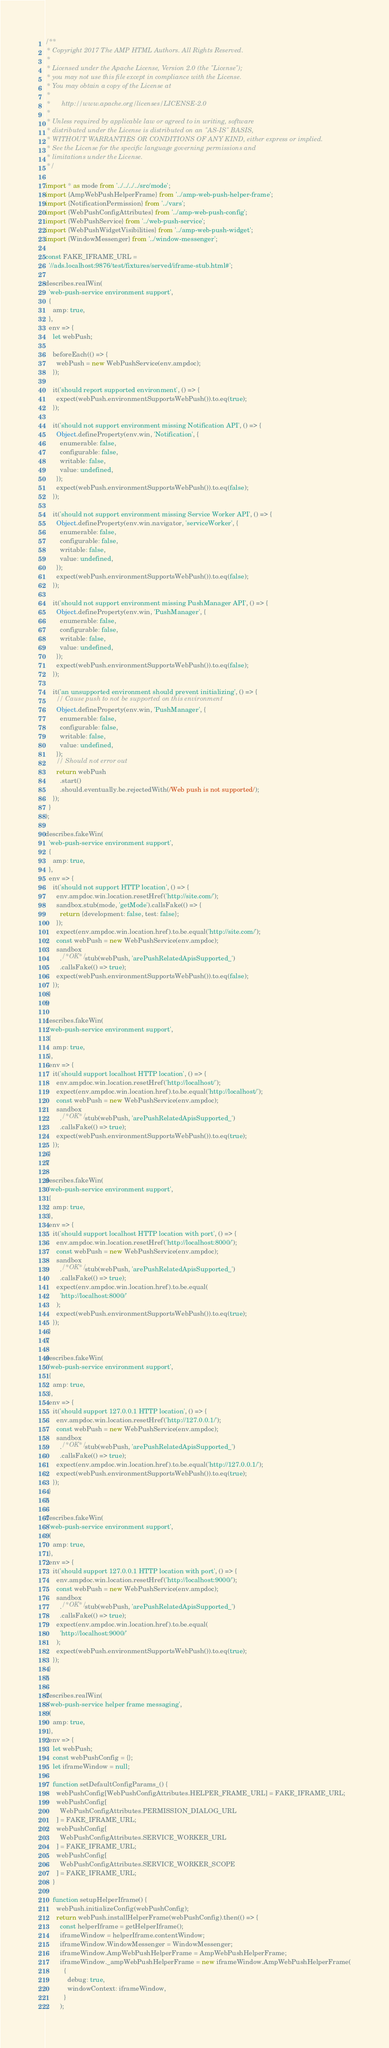Convert code to text. <code><loc_0><loc_0><loc_500><loc_500><_JavaScript_>/**
 * Copyright 2017 The AMP HTML Authors. All Rights Reserved.
 *
 * Licensed under the Apache License, Version 2.0 (the "License");
 * you may not use this file except in compliance with the License.
 * You may obtain a copy of the License at
 *
 *      http://www.apache.org/licenses/LICENSE-2.0
 *
 * Unless required by applicable law or agreed to in writing, software
 * distributed under the License is distributed on an "AS-IS" BASIS,
 * WITHOUT WARRANTIES OR CONDITIONS OF ANY KIND, either express or implied.
 * See the License for the specific language governing permissions and
 * limitations under the License.
 */

import * as mode from '../../../../src/mode';
import {AmpWebPushHelperFrame} from '../amp-web-push-helper-frame';
import {NotificationPermission} from '../vars';
import {WebPushConfigAttributes} from '../amp-web-push-config';
import {WebPushService} from '../web-push-service';
import {WebPushWidgetVisibilities} from '../amp-web-push-widget';
import {WindowMessenger} from '../window-messenger';

const FAKE_IFRAME_URL =
  '//ads.localhost:9876/test/fixtures/served/iframe-stub.html#';

describes.realWin(
  'web-push-service environment support',
  {
    amp: true,
  },
  env => {
    let webPush;

    beforeEach(() => {
      webPush = new WebPushService(env.ampdoc);
    });

    it('should report supported environment', () => {
      expect(webPush.environmentSupportsWebPush()).to.eq(true);
    });

    it('should not support environment missing Notification API', () => {
      Object.defineProperty(env.win, 'Notification', {
        enumerable: false,
        configurable: false,
        writable: false,
        value: undefined,
      });
      expect(webPush.environmentSupportsWebPush()).to.eq(false);
    });

    it('should not support environment missing Service Worker API', () => {
      Object.defineProperty(env.win.navigator, 'serviceWorker', {
        enumerable: false,
        configurable: false,
        writable: false,
        value: undefined,
      });
      expect(webPush.environmentSupportsWebPush()).to.eq(false);
    });

    it('should not support environment missing PushManager API', () => {
      Object.defineProperty(env.win, 'PushManager', {
        enumerable: false,
        configurable: false,
        writable: false,
        value: undefined,
      });
      expect(webPush.environmentSupportsWebPush()).to.eq(false);
    });

    it('an unsupported environment should prevent initializing', () => {
      // Cause push to not be supported on this environment
      Object.defineProperty(env.win, 'PushManager', {
        enumerable: false,
        configurable: false,
        writable: false,
        value: undefined,
      });
      // Should not error out
      return webPush
        .start()
        .should.eventually.be.rejectedWith(/Web push is not supported/);
    });
  }
);

describes.fakeWin(
  'web-push-service environment support',
  {
    amp: true,
  },
  env => {
    it('should not support HTTP location', () => {
      env.ampdoc.win.location.resetHref('http://site.com/');
      sandbox.stub(mode, 'getMode').callsFake(() => {
        return {development: false, test: false};
      });
      expect(env.ampdoc.win.location.href).to.be.equal('http://site.com/');
      const webPush = new WebPushService(env.ampdoc);
      sandbox
        ./*OK*/ stub(webPush, 'arePushRelatedApisSupported_')
        .callsFake(() => true);
      expect(webPush.environmentSupportsWebPush()).to.eq(false);
    });
  }
);

describes.fakeWin(
  'web-push-service environment support',
  {
    amp: true,
  },
  env => {
    it('should support localhost HTTP location', () => {
      env.ampdoc.win.location.resetHref('http://localhost/');
      expect(env.ampdoc.win.location.href).to.be.equal('http://localhost/');
      const webPush = new WebPushService(env.ampdoc);
      sandbox
        ./*OK*/ stub(webPush, 'arePushRelatedApisSupported_')
        .callsFake(() => true);
      expect(webPush.environmentSupportsWebPush()).to.eq(true);
    });
  }
);

describes.fakeWin(
  'web-push-service environment support',
  {
    amp: true,
  },
  env => {
    it('should support localhost HTTP location with port', () => {
      env.ampdoc.win.location.resetHref('http://localhost:8000/');
      const webPush = new WebPushService(env.ampdoc);
      sandbox
        ./*OK*/ stub(webPush, 'arePushRelatedApisSupported_')
        .callsFake(() => true);
      expect(env.ampdoc.win.location.href).to.be.equal(
        'http://localhost:8000/'
      );
      expect(webPush.environmentSupportsWebPush()).to.eq(true);
    });
  }
);

describes.fakeWin(
  'web-push-service environment support',
  {
    amp: true,
  },
  env => {
    it('should support 127.0.0.1 HTTP location', () => {
      env.ampdoc.win.location.resetHref('http://127.0.0.1/');
      const webPush = new WebPushService(env.ampdoc);
      sandbox
        ./*OK*/ stub(webPush, 'arePushRelatedApisSupported_')
        .callsFake(() => true);
      expect(env.ampdoc.win.location.href).to.be.equal('http://127.0.0.1/');
      expect(webPush.environmentSupportsWebPush()).to.eq(true);
    });
  }
);

describes.fakeWin(
  'web-push-service environment support',
  {
    amp: true,
  },
  env => {
    it('should support 127.0.0.1 HTTP location with port', () => {
      env.ampdoc.win.location.resetHref('http://localhost:9000/');
      const webPush = new WebPushService(env.ampdoc);
      sandbox
        ./*OK*/ stub(webPush, 'arePushRelatedApisSupported_')
        .callsFake(() => true);
      expect(env.ampdoc.win.location.href).to.be.equal(
        'http://localhost:9000/'
      );
      expect(webPush.environmentSupportsWebPush()).to.eq(true);
    });
  }
);

describes.realWin(
  'web-push-service helper frame messaging',
  {
    amp: true,
  },
  env => {
    let webPush;
    const webPushConfig = {};
    let iframeWindow = null;

    function setDefaultConfigParams_() {
      webPushConfig[WebPushConfigAttributes.HELPER_FRAME_URL] = FAKE_IFRAME_URL;
      webPushConfig[
        WebPushConfigAttributes.PERMISSION_DIALOG_URL
      ] = FAKE_IFRAME_URL;
      webPushConfig[
        WebPushConfigAttributes.SERVICE_WORKER_URL
      ] = FAKE_IFRAME_URL;
      webPushConfig[
        WebPushConfigAttributes.SERVICE_WORKER_SCOPE
      ] = FAKE_IFRAME_URL;
    }

    function setupHelperIframe() {
      webPush.initializeConfig(webPushConfig);
      return webPush.installHelperFrame(webPushConfig).then(() => {
        const helperIframe = getHelperIframe();
        iframeWindow = helperIframe.contentWindow;
        iframeWindow.WindowMessenger = WindowMessenger;
        iframeWindow.AmpWebPushHelperFrame = AmpWebPushHelperFrame;
        iframeWindow._ampWebPushHelperFrame = new iframeWindow.AmpWebPushHelperFrame(
          {
            debug: true,
            windowContext: iframeWindow,
          }
        );</code> 